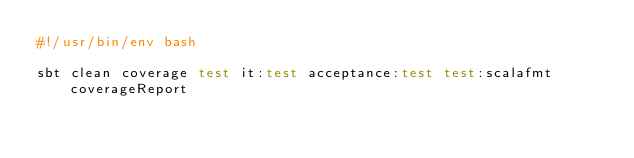<code> <loc_0><loc_0><loc_500><loc_500><_Bash_>#!/usr/bin/env bash

sbt clean coverage test it:test acceptance:test test:scalafmt coverageReport
</code> 